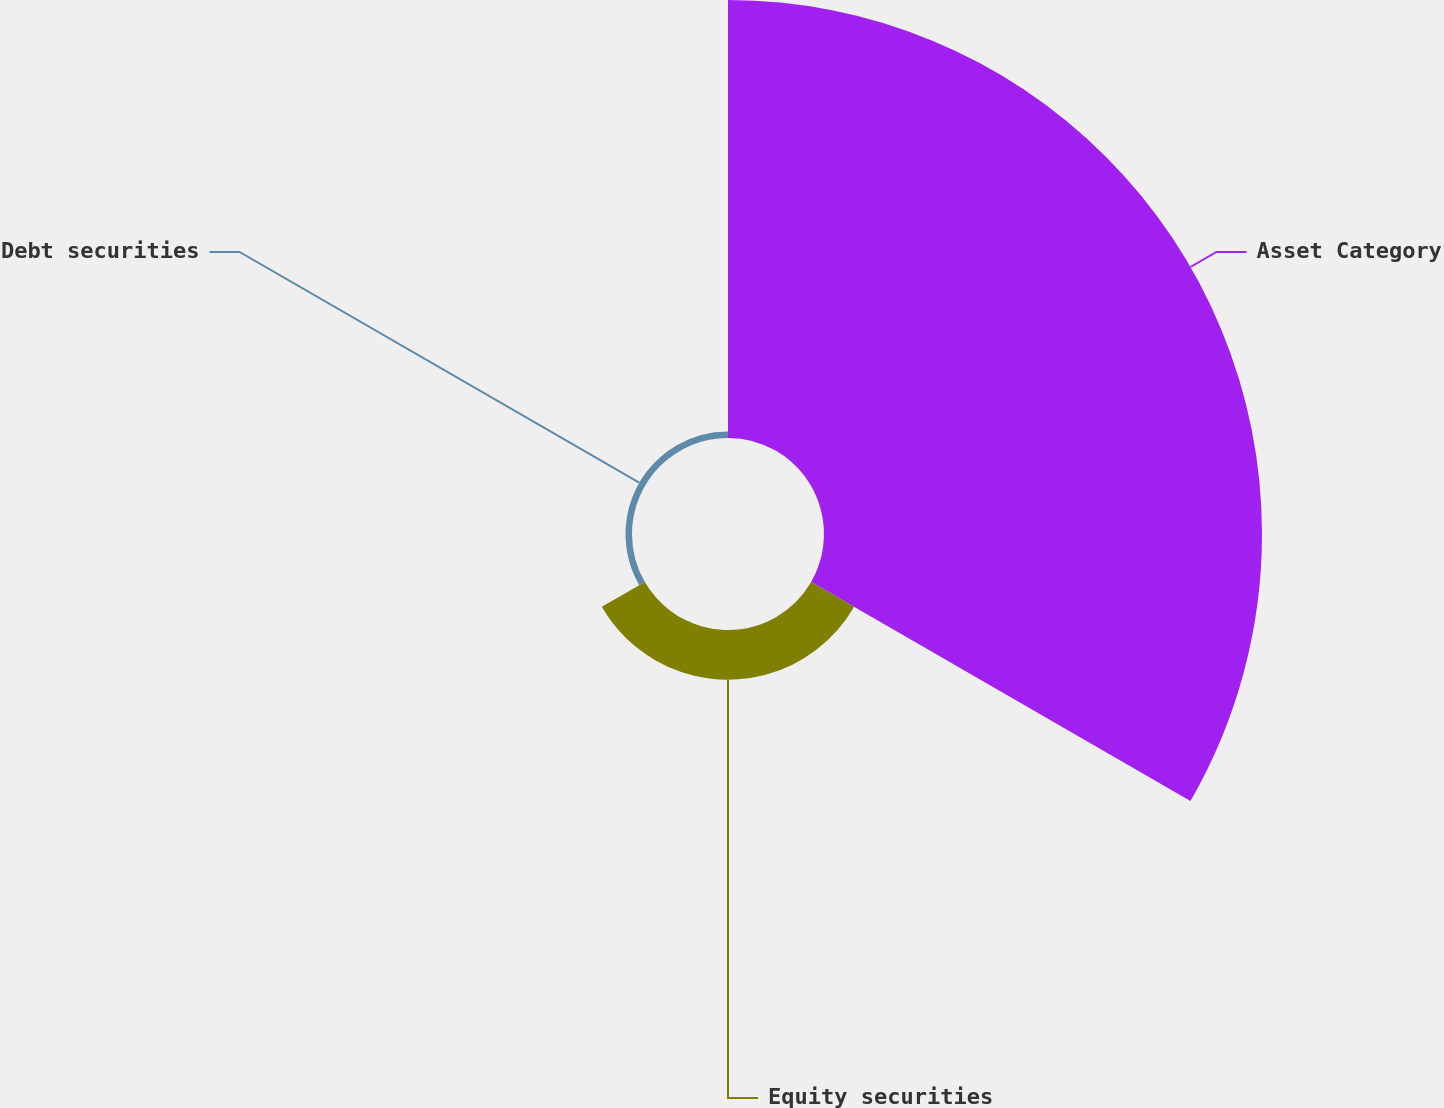<chart> <loc_0><loc_0><loc_500><loc_500><pie_chart><fcel>Asset Category<fcel>Equity securities<fcel>Debt securities<nl><fcel>88.62%<fcel>10.05%<fcel>1.32%<nl></chart> 